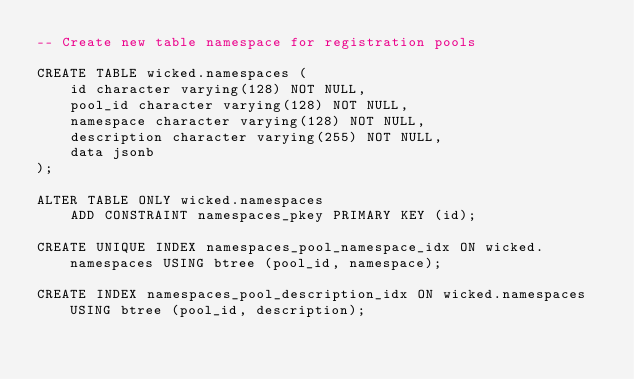<code> <loc_0><loc_0><loc_500><loc_500><_SQL_>-- Create new table namespace for registration pools

CREATE TABLE wicked.namespaces (
    id character varying(128) NOT NULL,
    pool_id character varying(128) NOT NULL,
    namespace character varying(128) NOT NULL,
    description character varying(255) NOT NULL,
    data jsonb
);

ALTER TABLE ONLY wicked.namespaces
    ADD CONSTRAINT namespaces_pkey PRIMARY KEY (id);

CREATE UNIQUE INDEX namespaces_pool_namespace_idx ON wicked.namespaces USING btree (pool_id, namespace);

CREATE INDEX namespaces_pool_description_idx ON wicked.namespaces USING btree (pool_id, description);
</code> 